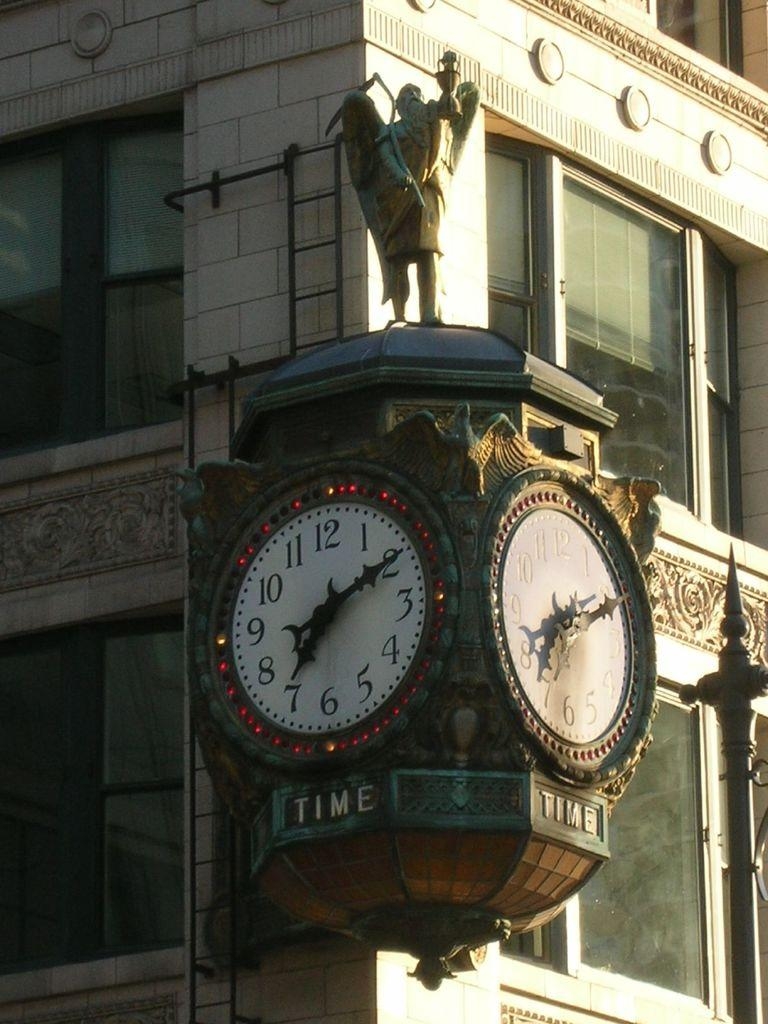Provide a one-sentence caption for the provided image. clocks on corner of building set at 7:10 and word time under each clock. 